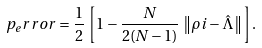Convert formula to latex. <formula><loc_0><loc_0><loc_500><loc_500>p _ { e } r r o r = \frac { 1 } { 2 } \, \left [ 1 - \frac { N } { 2 ( N - 1 ) } \, \left \| \rho i - \hat { \Lambda } \right \| \right ] .</formula> 